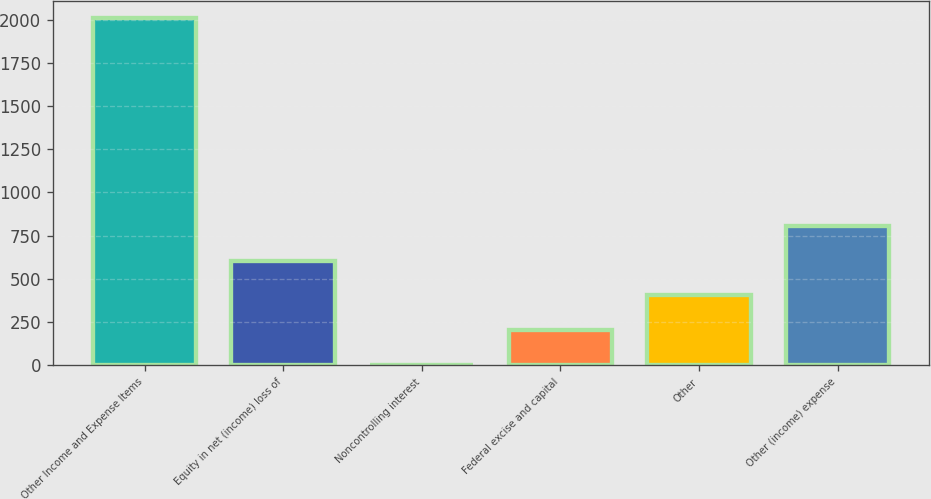<chart> <loc_0><loc_0><loc_500><loc_500><bar_chart><fcel>Other Income and Expense Items<fcel>Equity in net (income) loss of<fcel>Noncontrolling interest<fcel>Federal excise and capital<fcel>Other<fcel>Other (income) expense<nl><fcel>2009<fcel>604.8<fcel>3<fcel>203.6<fcel>404.2<fcel>805.4<nl></chart> 